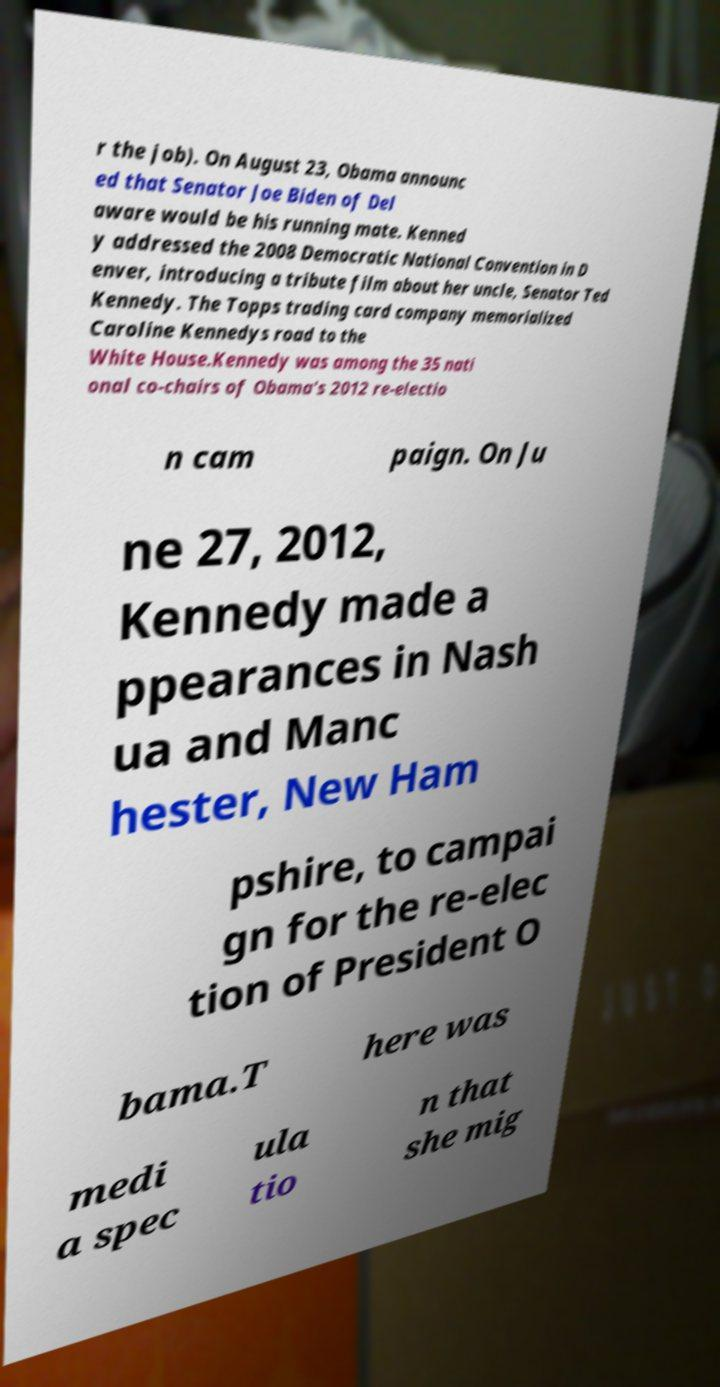Can you accurately transcribe the text from the provided image for me? r the job). On August 23, Obama announc ed that Senator Joe Biden of Del aware would be his running mate. Kenned y addressed the 2008 Democratic National Convention in D enver, introducing a tribute film about her uncle, Senator Ted Kennedy. The Topps trading card company memorialized Caroline Kennedys road to the White House.Kennedy was among the 35 nati onal co-chairs of Obama's 2012 re-electio n cam paign. On Ju ne 27, 2012, Kennedy made a ppearances in Nash ua and Manc hester, New Ham pshire, to campai gn for the re-elec tion of President O bama.T here was medi a spec ula tio n that she mig 